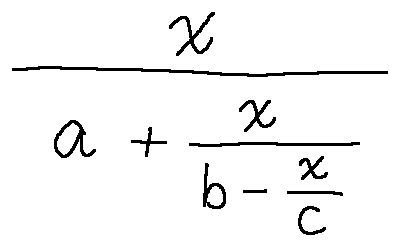<formula> <loc_0><loc_0><loc_500><loc_500>\frac { x } { a + \frac { x } { b - \frac { x } { c } } }</formula> 